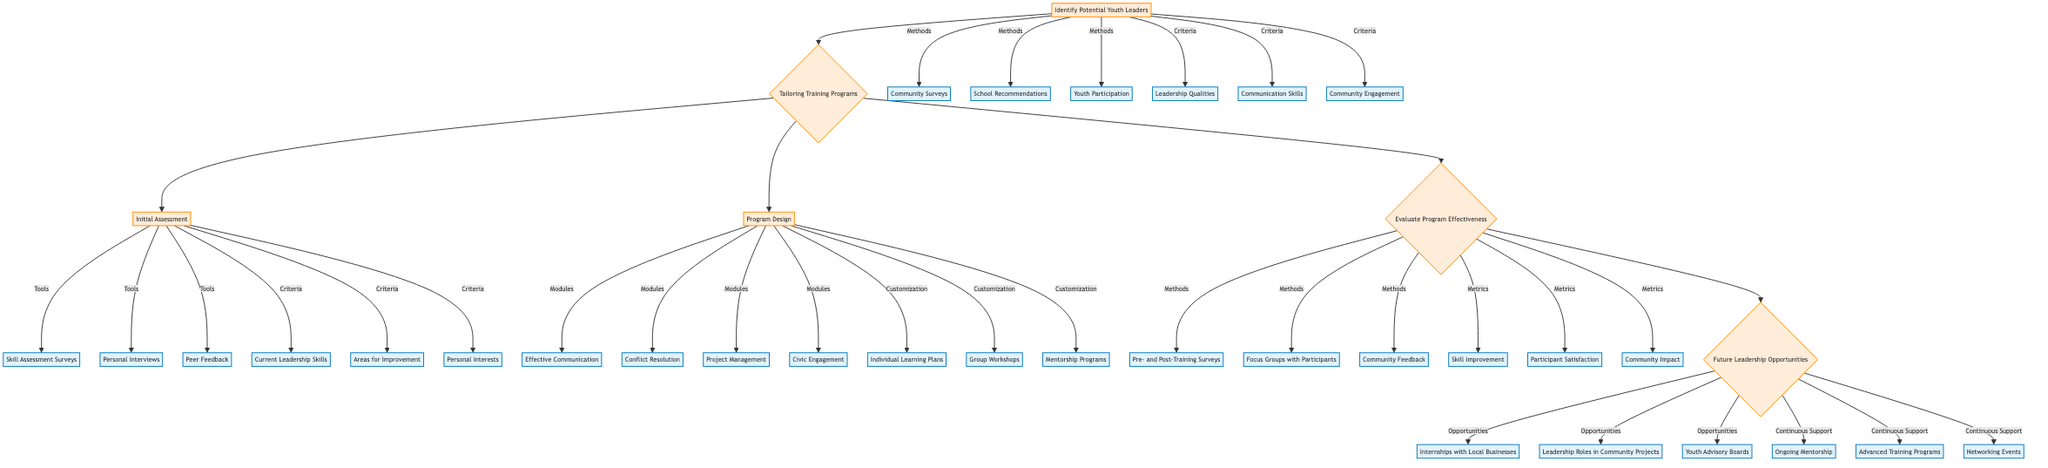What is the first step in the decision tree? The decision tree begins with the node labeled "Identify Potential Youth Leaders." This is the starting point from where the process unfolds.
Answer: Identify Potential Youth Leaders How many methods are listed for identifying potential youth leaders? There are three methods listed: Community Surveys, School Recommendations, and Youth Participation in Community Activities. These are the distinct methods mentioned under the identification process.
Answer: 3 What are the three criteria for identifying potential youth leaders? The criteria listed are Leadership Qualities, Communication Skills, and Community Engagement. These specify the qualities sought in potential leaders.
Answer: Leadership Qualities, Communication Skills, Community Engagement Which tools are used in the Initial Assessment? The tools used in the Initial Assessment include Skill Assessment Surveys, Personal Interviews, and Peer Feedback. These three tools help evaluate the candidates.
Answer: Skill Assessment Surveys, Personal Interviews, Peer Feedback What is the evaluation method that measures skill improvement? The method that measures skill improvement is the Pre- and Post-Training Surveys. These surveys assess the participants before and after the training to identify any skill enhancement.
Answer: Pre- and Post-Training Surveys How many modules are included in the Program Design? There are four modules included: Effective Communication, Conflict Resolution, Project Management, and Civic Engagement. This counts the distinct educational topics covered in the program.
Answer: 4 What are the two types of opportunities for future leadership mentioned? The two types of opportunities mentioned are Internships with Local Businesses and Leadership Roles in Community Projects. These emphasize direct experience and leadership responsibilities available for youth.
Answer: Internships with Local Businesses, Leadership Roles in Community Projects What is the continuous support offered for future leadership? The continuous support offered includes Ongoing Mentorship, Advanced Training Programs, and Networking Events. This support system is designed to help maintain and enhance the leadership skills developed.
Answer: Ongoing Mentorship, Advanced Training Programs, Networking Events Which method involves gathering feedback from the community? The method that involves gathering feedback from the community is labeled as Community Feedback. This method seeks external perspectives on the program's impact.
Answer: Community Feedback 